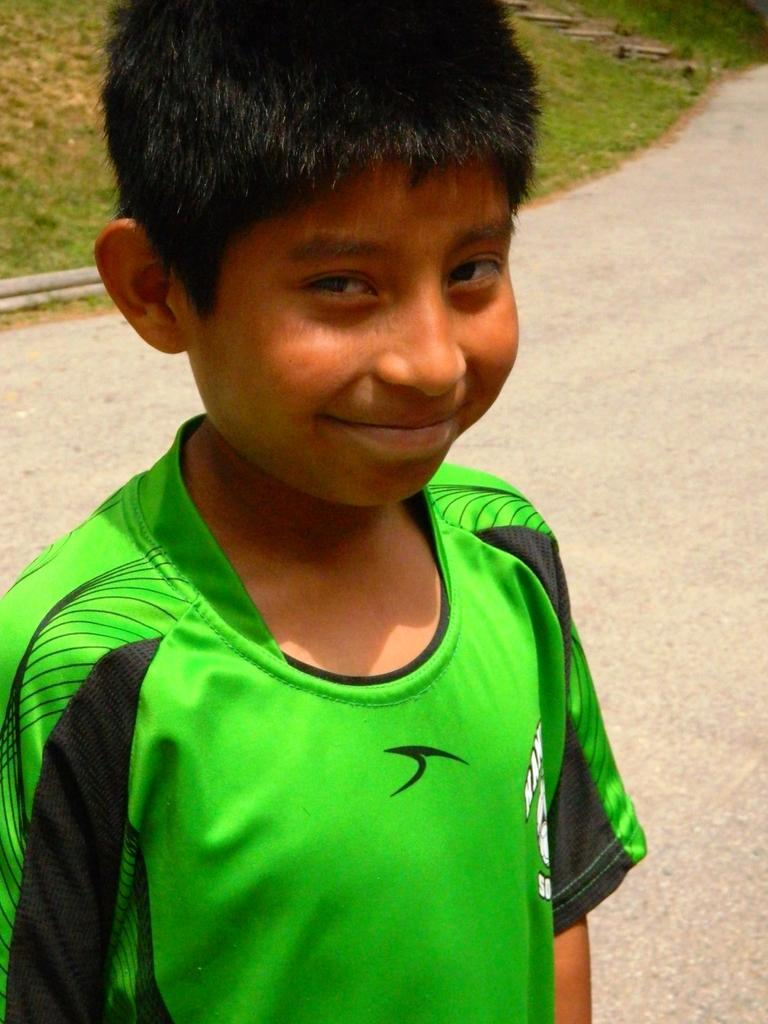What is the main subject of the image? The main subject of the image is a small boy. Where is the boy located in the image? The boy is standing on the road. What is the boy wearing in the image? The boy is wearing a green T-shirt. What expression does the boy have in the image? The boy has a smile on his face. What type of surface can be seen behind the boy? There is a grass surface visible behind the boy. What year is depicted in the image? The image does not depict a specific year; it is a photograph of a small boy. Can you hear the sound of a horn in the image? There is no sound present in the image, as it is a still photograph. 